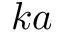<formula> <loc_0><loc_0><loc_500><loc_500>k a</formula> 